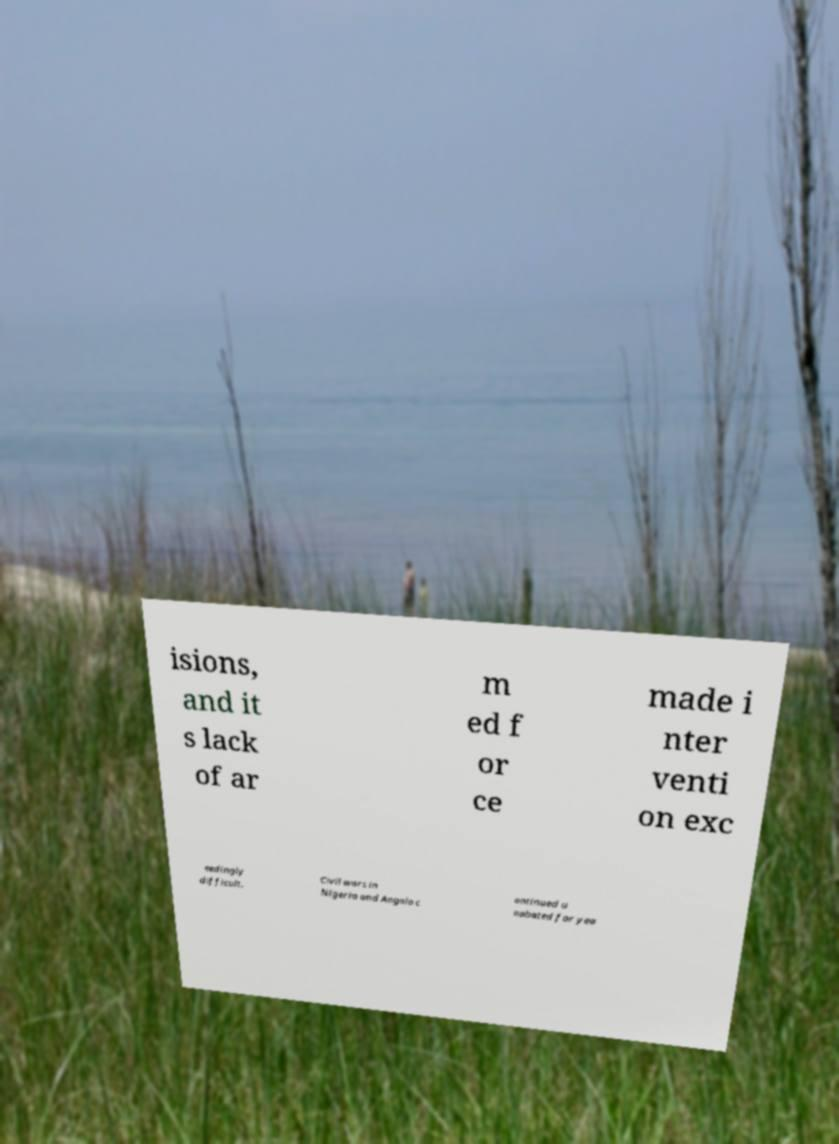For documentation purposes, I need the text within this image transcribed. Could you provide that? isions, and it s lack of ar m ed f or ce made i nter venti on exc eedingly difficult. Civil wars in Nigeria and Angola c ontinued u nabated for yea 